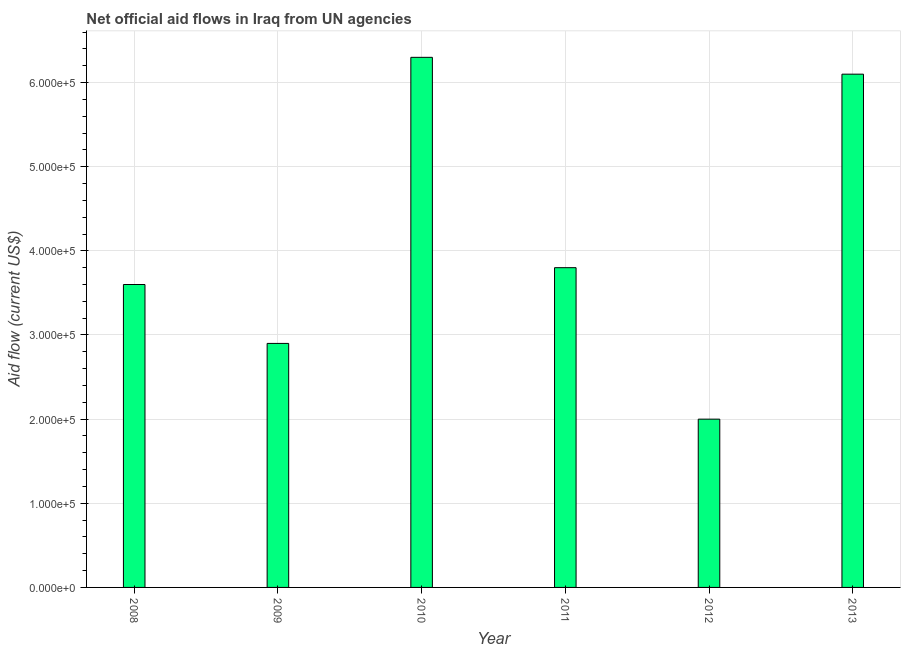What is the title of the graph?
Your answer should be compact. Net official aid flows in Iraq from UN agencies. What is the label or title of the X-axis?
Give a very brief answer. Year. What is the label or title of the Y-axis?
Keep it short and to the point. Aid flow (current US$). Across all years, what is the maximum net official flows from un agencies?
Make the answer very short. 6.30e+05. In which year was the net official flows from un agencies maximum?
Provide a short and direct response. 2010. In which year was the net official flows from un agencies minimum?
Offer a very short reply. 2012. What is the sum of the net official flows from un agencies?
Your answer should be compact. 2.47e+06. What is the average net official flows from un agencies per year?
Keep it short and to the point. 4.12e+05. What is the median net official flows from un agencies?
Give a very brief answer. 3.70e+05. Do a majority of the years between 2008 and 2012 (inclusive) have net official flows from un agencies greater than 60000 US$?
Your response must be concise. Yes. What is the ratio of the net official flows from un agencies in 2009 to that in 2013?
Offer a very short reply. 0.47. Is the net official flows from un agencies in 2011 less than that in 2012?
Give a very brief answer. No. Is the difference between the net official flows from un agencies in 2012 and 2013 greater than the difference between any two years?
Offer a terse response. No. Is the sum of the net official flows from un agencies in 2011 and 2012 greater than the maximum net official flows from un agencies across all years?
Make the answer very short. No. Are the values on the major ticks of Y-axis written in scientific E-notation?
Your response must be concise. Yes. What is the Aid flow (current US$) of 2008?
Your response must be concise. 3.60e+05. What is the Aid flow (current US$) in 2009?
Ensure brevity in your answer.  2.90e+05. What is the Aid flow (current US$) of 2010?
Provide a short and direct response. 6.30e+05. What is the Aid flow (current US$) in 2011?
Offer a very short reply. 3.80e+05. What is the difference between the Aid flow (current US$) in 2008 and 2009?
Your answer should be compact. 7.00e+04. What is the difference between the Aid flow (current US$) in 2008 and 2010?
Keep it short and to the point. -2.70e+05. What is the difference between the Aid flow (current US$) in 2008 and 2012?
Provide a short and direct response. 1.60e+05. What is the difference between the Aid flow (current US$) in 2009 and 2010?
Provide a succinct answer. -3.40e+05. What is the difference between the Aid flow (current US$) in 2009 and 2012?
Offer a terse response. 9.00e+04. What is the difference between the Aid flow (current US$) in 2009 and 2013?
Provide a short and direct response. -3.20e+05. What is the difference between the Aid flow (current US$) in 2010 and 2012?
Your response must be concise. 4.30e+05. What is the difference between the Aid flow (current US$) in 2010 and 2013?
Provide a short and direct response. 2.00e+04. What is the difference between the Aid flow (current US$) in 2012 and 2013?
Make the answer very short. -4.10e+05. What is the ratio of the Aid flow (current US$) in 2008 to that in 2009?
Provide a succinct answer. 1.24. What is the ratio of the Aid flow (current US$) in 2008 to that in 2010?
Provide a short and direct response. 0.57. What is the ratio of the Aid flow (current US$) in 2008 to that in 2011?
Offer a very short reply. 0.95. What is the ratio of the Aid flow (current US$) in 2008 to that in 2012?
Your answer should be very brief. 1.8. What is the ratio of the Aid flow (current US$) in 2008 to that in 2013?
Make the answer very short. 0.59. What is the ratio of the Aid flow (current US$) in 2009 to that in 2010?
Provide a short and direct response. 0.46. What is the ratio of the Aid flow (current US$) in 2009 to that in 2011?
Provide a succinct answer. 0.76. What is the ratio of the Aid flow (current US$) in 2009 to that in 2012?
Provide a short and direct response. 1.45. What is the ratio of the Aid flow (current US$) in 2009 to that in 2013?
Make the answer very short. 0.47. What is the ratio of the Aid flow (current US$) in 2010 to that in 2011?
Keep it short and to the point. 1.66. What is the ratio of the Aid flow (current US$) in 2010 to that in 2012?
Offer a terse response. 3.15. What is the ratio of the Aid flow (current US$) in 2010 to that in 2013?
Offer a very short reply. 1.03. What is the ratio of the Aid flow (current US$) in 2011 to that in 2012?
Keep it short and to the point. 1.9. What is the ratio of the Aid flow (current US$) in 2011 to that in 2013?
Keep it short and to the point. 0.62. What is the ratio of the Aid flow (current US$) in 2012 to that in 2013?
Your answer should be very brief. 0.33. 